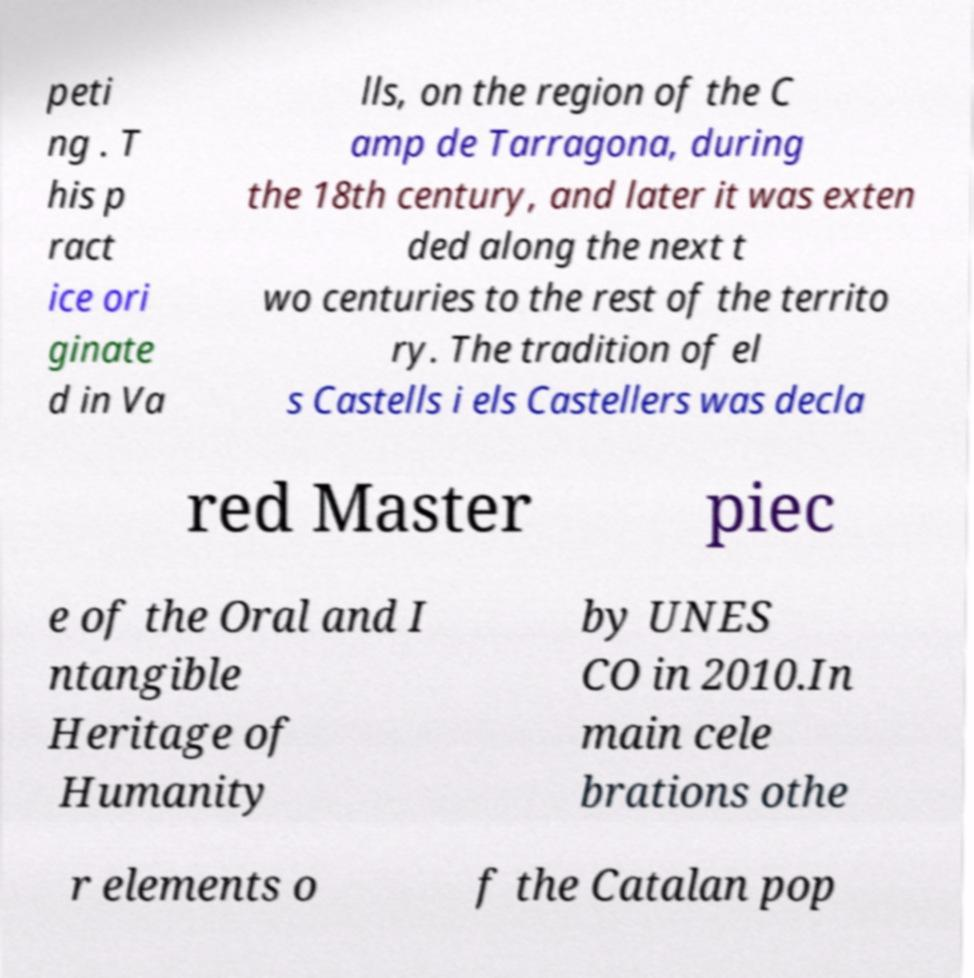Can you read and provide the text displayed in the image?This photo seems to have some interesting text. Can you extract and type it out for me? peti ng . T his p ract ice ori ginate d in Va lls, on the region of the C amp de Tarragona, during the 18th century, and later it was exten ded along the next t wo centuries to the rest of the territo ry. The tradition of el s Castells i els Castellers was decla red Master piec e of the Oral and I ntangible Heritage of Humanity by UNES CO in 2010.In main cele brations othe r elements o f the Catalan pop 